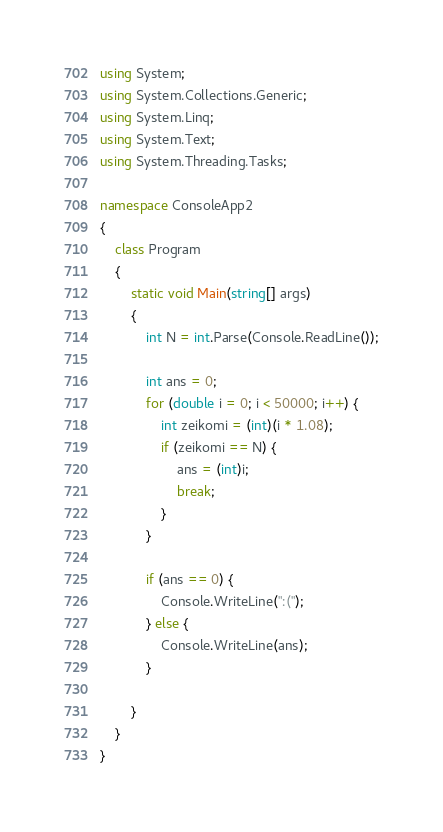<code> <loc_0><loc_0><loc_500><loc_500><_C#_>using System;
using System.Collections.Generic;
using System.Linq;
using System.Text;
using System.Threading.Tasks;

namespace ConsoleApp2
{
    class Program
    {
        static void Main(string[] args)
        {
            int N = int.Parse(Console.ReadLine());

            int ans = 0;
            for (double i = 0; i < 50000; i++) {
                int zeikomi = (int)(i * 1.08);
                if (zeikomi == N) {
                    ans = (int)i;
                    break;
                }
            }

            if (ans == 0) {
                Console.WriteLine(":(");
            } else {
                Console.WriteLine(ans);
            }

        }
    }
}
</code> 